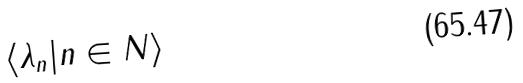<formula> <loc_0><loc_0><loc_500><loc_500>\langle \lambda _ { n } | n \in N \rangle</formula> 